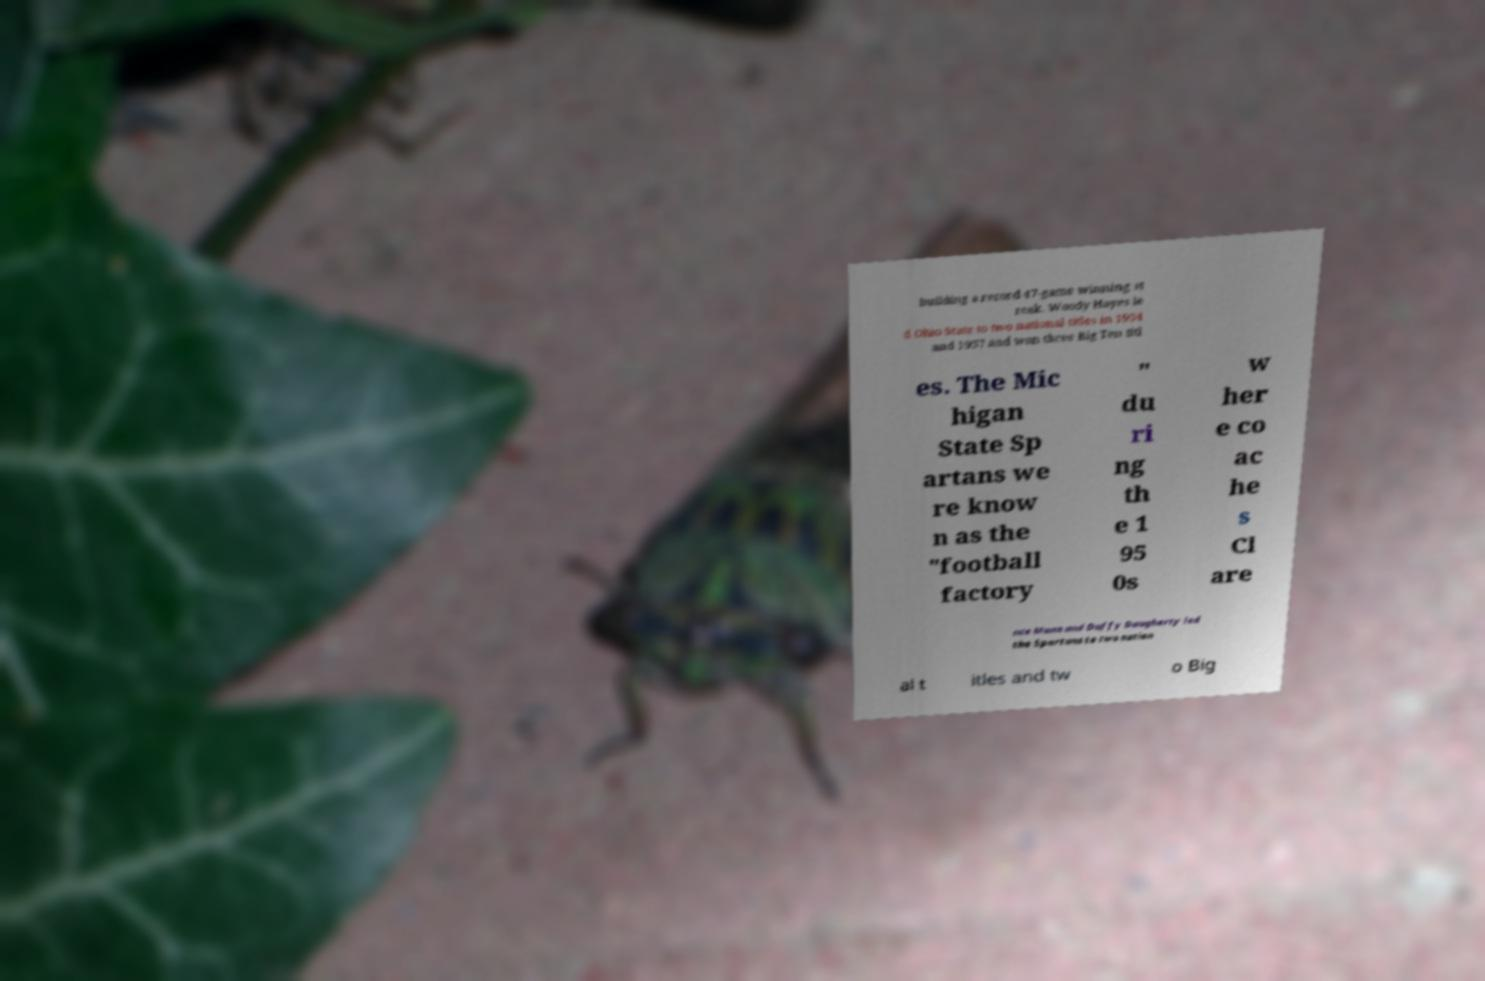Please read and relay the text visible in this image. What does it say? building a record 47-game winning st reak. Woody Hayes le d Ohio State to two national titles in 1954 and 1957 and won three Big Ten titl es. The Mic higan State Sp artans we re know n as the "football factory " du ri ng th e 1 95 0s w her e co ac he s Cl are nce Munn and Duffy Daugherty led the Spartans to two nation al t itles and tw o Big 